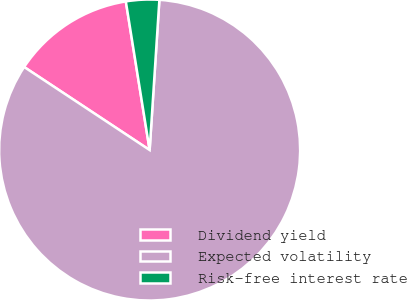<chart> <loc_0><loc_0><loc_500><loc_500><pie_chart><fcel>Dividend yield<fcel>Expected volatility<fcel>Risk-free interest rate<nl><fcel>13.17%<fcel>83.27%<fcel>3.56%<nl></chart> 